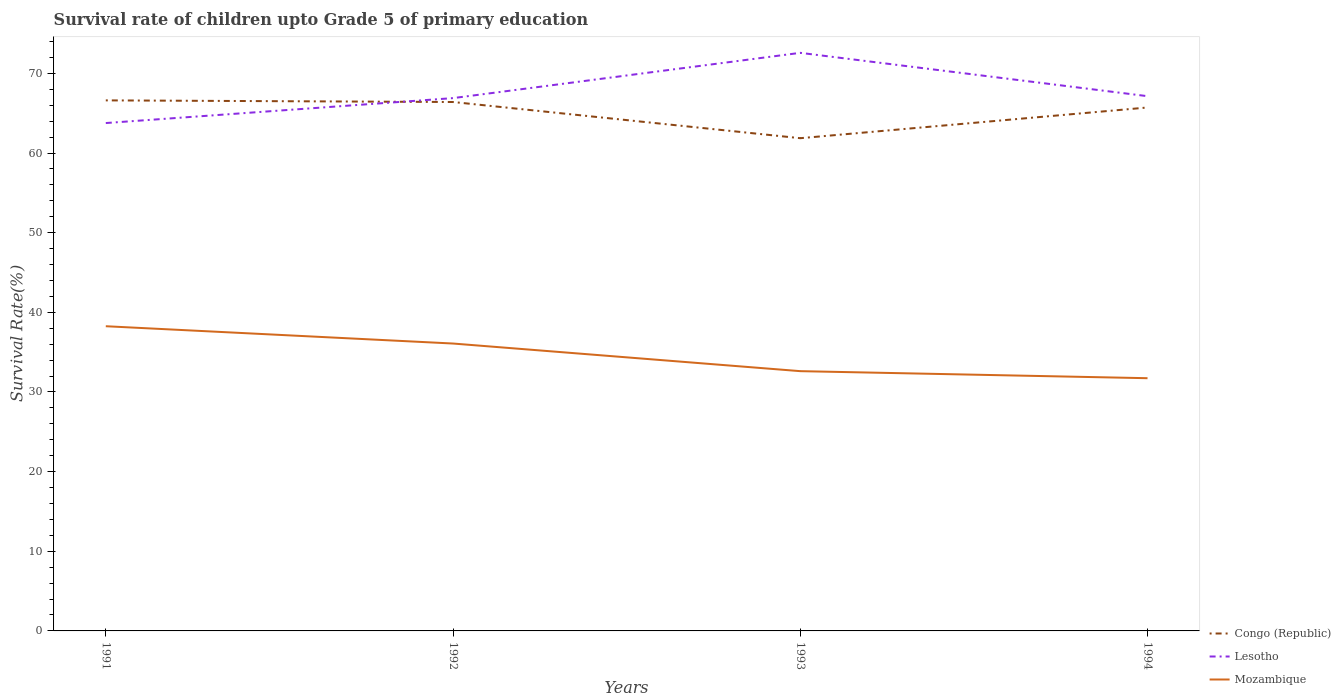Does the line corresponding to Congo (Republic) intersect with the line corresponding to Lesotho?
Your answer should be very brief. Yes. Is the number of lines equal to the number of legend labels?
Provide a short and direct response. Yes. Across all years, what is the maximum survival rate of children in Mozambique?
Your response must be concise. 31.73. In which year was the survival rate of children in Mozambique maximum?
Give a very brief answer. 1994. What is the total survival rate of children in Mozambique in the graph?
Your answer should be very brief. 2.17. What is the difference between the highest and the second highest survival rate of children in Mozambique?
Your answer should be compact. 6.53. What is the difference between the highest and the lowest survival rate of children in Lesotho?
Ensure brevity in your answer.  1. Is the survival rate of children in Mozambique strictly greater than the survival rate of children in Lesotho over the years?
Your response must be concise. Yes. How many years are there in the graph?
Offer a very short reply. 4. Are the values on the major ticks of Y-axis written in scientific E-notation?
Keep it short and to the point. No. Where does the legend appear in the graph?
Offer a terse response. Bottom right. How many legend labels are there?
Your answer should be very brief. 3. What is the title of the graph?
Your answer should be very brief. Survival rate of children upto Grade 5 of primary education. Does "South Africa" appear as one of the legend labels in the graph?
Your response must be concise. No. What is the label or title of the Y-axis?
Provide a succinct answer. Survival Rate(%). What is the Survival Rate(%) in Congo (Republic) in 1991?
Make the answer very short. 66.62. What is the Survival Rate(%) in Lesotho in 1991?
Give a very brief answer. 63.77. What is the Survival Rate(%) in Mozambique in 1991?
Your answer should be compact. 38.26. What is the Survival Rate(%) in Congo (Republic) in 1992?
Your response must be concise. 66.41. What is the Survival Rate(%) in Lesotho in 1992?
Make the answer very short. 66.9. What is the Survival Rate(%) in Mozambique in 1992?
Your answer should be very brief. 36.08. What is the Survival Rate(%) of Congo (Republic) in 1993?
Offer a terse response. 61.87. What is the Survival Rate(%) of Lesotho in 1993?
Your answer should be compact. 72.58. What is the Survival Rate(%) in Mozambique in 1993?
Your answer should be compact. 32.62. What is the Survival Rate(%) in Congo (Republic) in 1994?
Provide a succinct answer. 65.72. What is the Survival Rate(%) in Lesotho in 1994?
Provide a short and direct response. 67.14. What is the Survival Rate(%) in Mozambique in 1994?
Give a very brief answer. 31.73. Across all years, what is the maximum Survival Rate(%) of Congo (Republic)?
Make the answer very short. 66.62. Across all years, what is the maximum Survival Rate(%) in Lesotho?
Give a very brief answer. 72.58. Across all years, what is the maximum Survival Rate(%) of Mozambique?
Give a very brief answer. 38.26. Across all years, what is the minimum Survival Rate(%) in Congo (Republic)?
Your answer should be compact. 61.87. Across all years, what is the minimum Survival Rate(%) in Lesotho?
Ensure brevity in your answer.  63.77. Across all years, what is the minimum Survival Rate(%) of Mozambique?
Ensure brevity in your answer.  31.73. What is the total Survival Rate(%) of Congo (Republic) in the graph?
Offer a very short reply. 260.61. What is the total Survival Rate(%) in Lesotho in the graph?
Your answer should be very brief. 270.39. What is the total Survival Rate(%) of Mozambique in the graph?
Keep it short and to the point. 138.69. What is the difference between the Survival Rate(%) in Congo (Republic) in 1991 and that in 1992?
Provide a succinct answer. 0.21. What is the difference between the Survival Rate(%) of Lesotho in 1991 and that in 1992?
Give a very brief answer. -3.13. What is the difference between the Survival Rate(%) of Mozambique in 1991 and that in 1992?
Provide a short and direct response. 2.17. What is the difference between the Survival Rate(%) in Congo (Republic) in 1991 and that in 1993?
Provide a short and direct response. 4.75. What is the difference between the Survival Rate(%) in Lesotho in 1991 and that in 1993?
Provide a succinct answer. -8.81. What is the difference between the Survival Rate(%) in Mozambique in 1991 and that in 1993?
Ensure brevity in your answer.  5.64. What is the difference between the Survival Rate(%) of Congo (Republic) in 1991 and that in 1994?
Provide a succinct answer. 0.89. What is the difference between the Survival Rate(%) in Lesotho in 1991 and that in 1994?
Your answer should be very brief. -3.37. What is the difference between the Survival Rate(%) of Mozambique in 1991 and that in 1994?
Ensure brevity in your answer.  6.53. What is the difference between the Survival Rate(%) in Congo (Republic) in 1992 and that in 1993?
Give a very brief answer. 4.54. What is the difference between the Survival Rate(%) of Lesotho in 1992 and that in 1993?
Keep it short and to the point. -5.68. What is the difference between the Survival Rate(%) of Mozambique in 1992 and that in 1993?
Offer a very short reply. 3.47. What is the difference between the Survival Rate(%) in Congo (Republic) in 1992 and that in 1994?
Make the answer very short. 0.69. What is the difference between the Survival Rate(%) in Lesotho in 1992 and that in 1994?
Keep it short and to the point. -0.24. What is the difference between the Survival Rate(%) in Mozambique in 1992 and that in 1994?
Make the answer very short. 4.35. What is the difference between the Survival Rate(%) in Congo (Republic) in 1993 and that in 1994?
Make the answer very short. -3.86. What is the difference between the Survival Rate(%) in Lesotho in 1993 and that in 1994?
Offer a very short reply. 5.44. What is the difference between the Survival Rate(%) of Mozambique in 1993 and that in 1994?
Your answer should be compact. 0.88. What is the difference between the Survival Rate(%) in Congo (Republic) in 1991 and the Survival Rate(%) in Lesotho in 1992?
Your answer should be compact. -0.29. What is the difference between the Survival Rate(%) in Congo (Republic) in 1991 and the Survival Rate(%) in Mozambique in 1992?
Your answer should be compact. 30.53. What is the difference between the Survival Rate(%) in Lesotho in 1991 and the Survival Rate(%) in Mozambique in 1992?
Keep it short and to the point. 27.68. What is the difference between the Survival Rate(%) of Congo (Republic) in 1991 and the Survival Rate(%) of Lesotho in 1993?
Ensure brevity in your answer.  -5.97. What is the difference between the Survival Rate(%) of Congo (Republic) in 1991 and the Survival Rate(%) of Mozambique in 1993?
Keep it short and to the point. 34. What is the difference between the Survival Rate(%) of Lesotho in 1991 and the Survival Rate(%) of Mozambique in 1993?
Your answer should be very brief. 31.15. What is the difference between the Survival Rate(%) in Congo (Republic) in 1991 and the Survival Rate(%) in Lesotho in 1994?
Offer a terse response. -0.53. What is the difference between the Survival Rate(%) in Congo (Republic) in 1991 and the Survival Rate(%) in Mozambique in 1994?
Your answer should be very brief. 34.88. What is the difference between the Survival Rate(%) of Lesotho in 1991 and the Survival Rate(%) of Mozambique in 1994?
Your answer should be very brief. 32.04. What is the difference between the Survival Rate(%) of Congo (Republic) in 1992 and the Survival Rate(%) of Lesotho in 1993?
Your answer should be compact. -6.17. What is the difference between the Survival Rate(%) of Congo (Republic) in 1992 and the Survival Rate(%) of Mozambique in 1993?
Make the answer very short. 33.79. What is the difference between the Survival Rate(%) in Lesotho in 1992 and the Survival Rate(%) in Mozambique in 1993?
Offer a very short reply. 34.28. What is the difference between the Survival Rate(%) in Congo (Republic) in 1992 and the Survival Rate(%) in Lesotho in 1994?
Offer a very short reply. -0.73. What is the difference between the Survival Rate(%) in Congo (Republic) in 1992 and the Survival Rate(%) in Mozambique in 1994?
Your answer should be very brief. 34.68. What is the difference between the Survival Rate(%) in Lesotho in 1992 and the Survival Rate(%) in Mozambique in 1994?
Your answer should be very brief. 35.17. What is the difference between the Survival Rate(%) in Congo (Republic) in 1993 and the Survival Rate(%) in Lesotho in 1994?
Offer a very short reply. -5.28. What is the difference between the Survival Rate(%) in Congo (Republic) in 1993 and the Survival Rate(%) in Mozambique in 1994?
Offer a terse response. 30.14. What is the difference between the Survival Rate(%) of Lesotho in 1993 and the Survival Rate(%) of Mozambique in 1994?
Offer a terse response. 40.85. What is the average Survival Rate(%) in Congo (Republic) per year?
Offer a very short reply. 65.15. What is the average Survival Rate(%) in Lesotho per year?
Provide a succinct answer. 67.6. What is the average Survival Rate(%) of Mozambique per year?
Provide a succinct answer. 34.67. In the year 1991, what is the difference between the Survival Rate(%) in Congo (Republic) and Survival Rate(%) in Lesotho?
Give a very brief answer. 2.85. In the year 1991, what is the difference between the Survival Rate(%) of Congo (Republic) and Survival Rate(%) of Mozambique?
Offer a terse response. 28.36. In the year 1991, what is the difference between the Survival Rate(%) in Lesotho and Survival Rate(%) in Mozambique?
Your answer should be compact. 25.51. In the year 1992, what is the difference between the Survival Rate(%) of Congo (Republic) and Survival Rate(%) of Lesotho?
Make the answer very short. -0.49. In the year 1992, what is the difference between the Survival Rate(%) in Congo (Republic) and Survival Rate(%) in Mozambique?
Ensure brevity in your answer.  30.33. In the year 1992, what is the difference between the Survival Rate(%) in Lesotho and Survival Rate(%) in Mozambique?
Offer a very short reply. 30.82. In the year 1993, what is the difference between the Survival Rate(%) in Congo (Republic) and Survival Rate(%) in Lesotho?
Your response must be concise. -10.72. In the year 1993, what is the difference between the Survival Rate(%) in Congo (Republic) and Survival Rate(%) in Mozambique?
Provide a succinct answer. 29.25. In the year 1993, what is the difference between the Survival Rate(%) in Lesotho and Survival Rate(%) in Mozambique?
Offer a very short reply. 39.97. In the year 1994, what is the difference between the Survival Rate(%) of Congo (Republic) and Survival Rate(%) of Lesotho?
Your answer should be compact. -1.42. In the year 1994, what is the difference between the Survival Rate(%) in Congo (Republic) and Survival Rate(%) in Mozambique?
Offer a terse response. 33.99. In the year 1994, what is the difference between the Survival Rate(%) of Lesotho and Survival Rate(%) of Mozambique?
Your answer should be very brief. 35.41. What is the ratio of the Survival Rate(%) of Congo (Republic) in 1991 to that in 1992?
Your answer should be very brief. 1. What is the ratio of the Survival Rate(%) of Lesotho in 1991 to that in 1992?
Offer a terse response. 0.95. What is the ratio of the Survival Rate(%) in Mozambique in 1991 to that in 1992?
Offer a very short reply. 1.06. What is the ratio of the Survival Rate(%) of Congo (Republic) in 1991 to that in 1993?
Make the answer very short. 1.08. What is the ratio of the Survival Rate(%) in Lesotho in 1991 to that in 1993?
Provide a short and direct response. 0.88. What is the ratio of the Survival Rate(%) in Mozambique in 1991 to that in 1993?
Offer a terse response. 1.17. What is the ratio of the Survival Rate(%) in Congo (Republic) in 1991 to that in 1994?
Keep it short and to the point. 1.01. What is the ratio of the Survival Rate(%) of Lesotho in 1991 to that in 1994?
Keep it short and to the point. 0.95. What is the ratio of the Survival Rate(%) in Mozambique in 1991 to that in 1994?
Keep it short and to the point. 1.21. What is the ratio of the Survival Rate(%) of Congo (Republic) in 1992 to that in 1993?
Offer a terse response. 1.07. What is the ratio of the Survival Rate(%) of Lesotho in 1992 to that in 1993?
Provide a succinct answer. 0.92. What is the ratio of the Survival Rate(%) in Mozambique in 1992 to that in 1993?
Your answer should be compact. 1.11. What is the ratio of the Survival Rate(%) of Congo (Republic) in 1992 to that in 1994?
Make the answer very short. 1.01. What is the ratio of the Survival Rate(%) of Lesotho in 1992 to that in 1994?
Your answer should be very brief. 1. What is the ratio of the Survival Rate(%) of Mozambique in 1992 to that in 1994?
Your response must be concise. 1.14. What is the ratio of the Survival Rate(%) in Congo (Republic) in 1993 to that in 1994?
Your answer should be compact. 0.94. What is the ratio of the Survival Rate(%) of Lesotho in 1993 to that in 1994?
Your answer should be compact. 1.08. What is the ratio of the Survival Rate(%) of Mozambique in 1993 to that in 1994?
Offer a very short reply. 1.03. What is the difference between the highest and the second highest Survival Rate(%) of Congo (Republic)?
Offer a very short reply. 0.21. What is the difference between the highest and the second highest Survival Rate(%) in Lesotho?
Your response must be concise. 5.44. What is the difference between the highest and the second highest Survival Rate(%) in Mozambique?
Provide a succinct answer. 2.17. What is the difference between the highest and the lowest Survival Rate(%) in Congo (Republic)?
Your answer should be very brief. 4.75. What is the difference between the highest and the lowest Survival Rate(%) of Lesotho?
Ensure brevity in your answer.  8.81. What is the difference between the highest and the lowest Survival Rate(%) of Mozambique?
Your response must be concise. 6.53. 